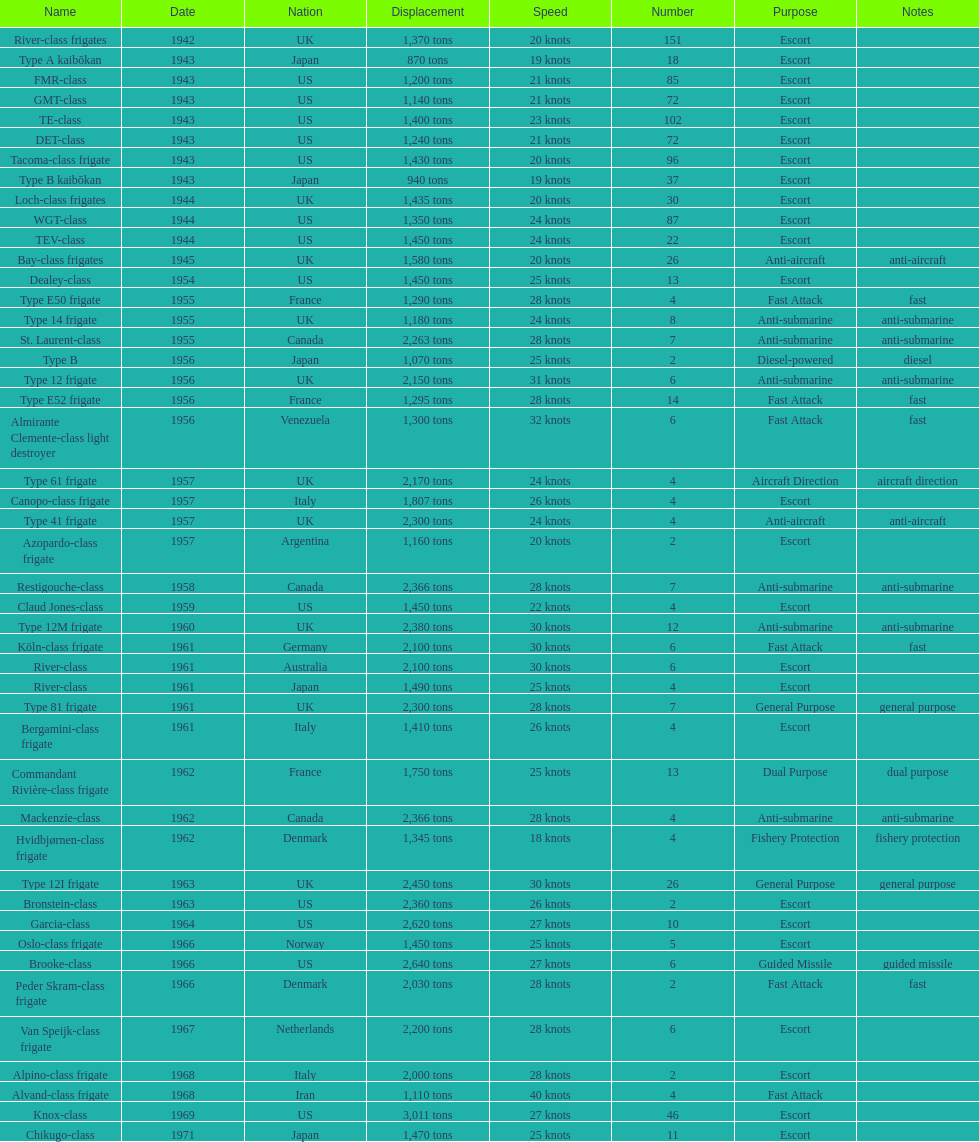Which name has the largest displacement? Knox-class. 